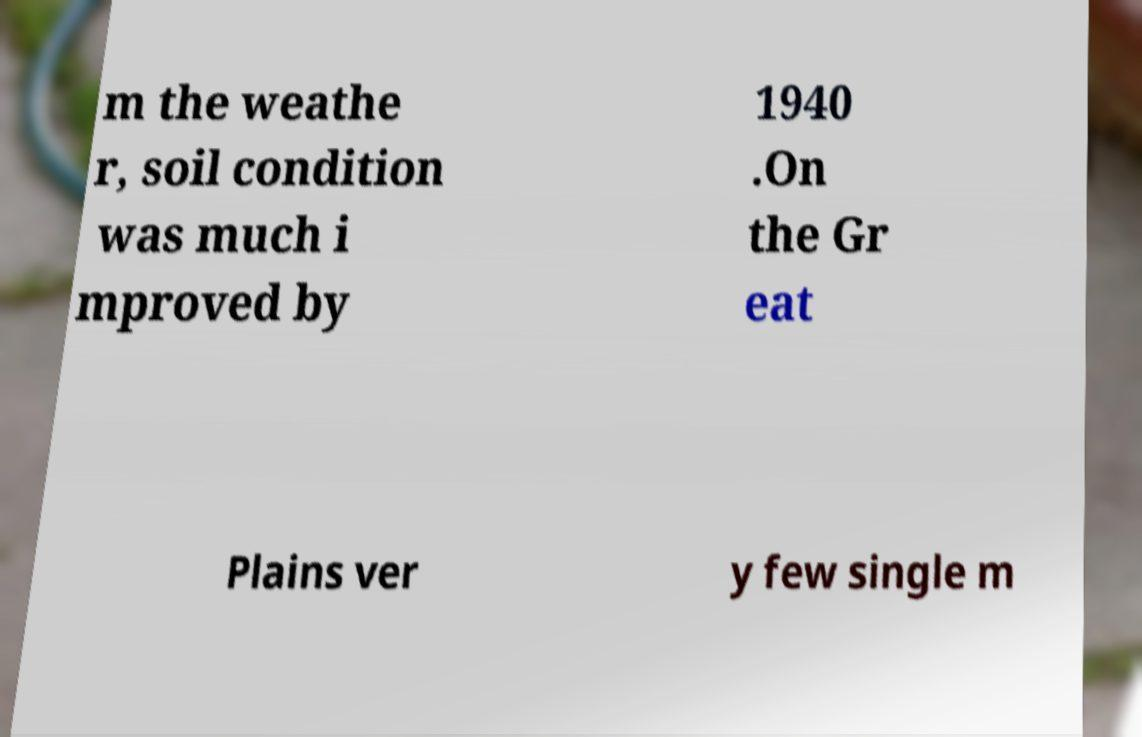Can you read and provide the text displayed in the image?This photo seems to have some interesting text. Can you extract and type it out for me? m the weathe r, soil condition was much i mproved by 1940 .On the Gr eat Plains ver y few single m 